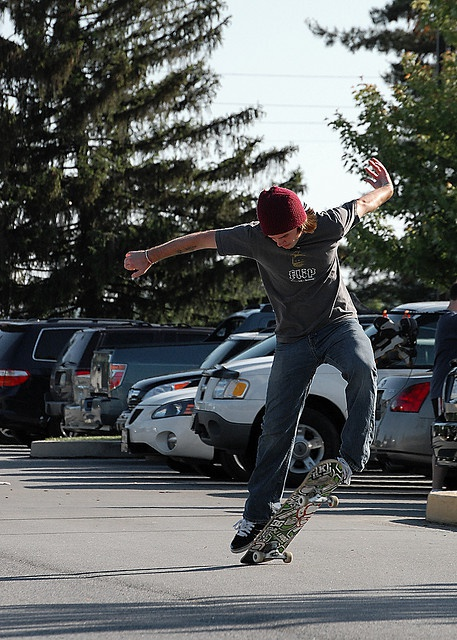Describe the objects in this image and their specific colors. I can see people in black, gray, darkgray, and lightgray tones, car in black and gray tones, car in black and gray tones, car in black, navy, blue, and gray tones, and car in black, maroon, gray, and navy tones in this image. 